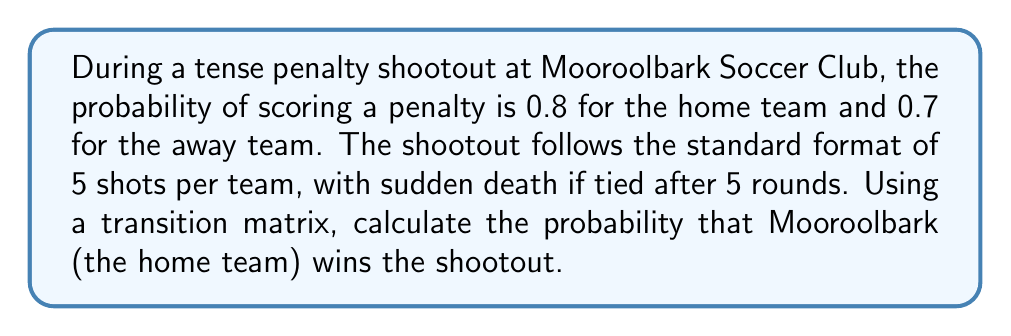Give your solution to this math problem. Let's approach this step-by-step using a transition matrix:

1) First, we need to set up our transition matrix. Let's define our states as:
   0 = Mooroolbark wins
   1 = Away team wins
   2 = Tie (continue to sudden death)

2) Our transition matrix P will be:

   $$P = \begin{bmatrix}
   1 & 0 & 0 \\
   0 & 1 & 0 \\
   p_m & p_a & 1-p_m-p_a
   \end{bmatrix}$$

   Where $p_m$ is the probability of Mooroolbark winning in sudden death, and $p_a$ is the probability of the away team winning in sudden death.

3) To calculate $p_m$ and $p_a$, we need to consider the probability of scoring for each team:

   $p_m = 0.8 * (1-0.7) = 0.24$
   $p_a = 0.7 * (1-0.8) = 0.14$

4) Now our transition matrix becomes:

   $$P = \begin{bmatrix}
   1 & 0 & 0 \\
   0 & 1 & 0 \\
   0.24 & 0.14 & 0.62
   \end{bmatrix}$$

5) To find the probability of each outcome after the initial 5 rounds, we need to calculate the probability of each possible score combination. Let's use the binomial distribution:

   $P(\text{Mooroolbark score} = k) = \binom{5}{k}(0.8)^k(0.2)^{5-k}$
   $P(\text{Away team score} = j) = \binom{5}{j}(0.7)^j(0.3)^{5-j}$

6) We can now calculate the probability of each outcome:

   Mooroolbark wins: $\sum_{k=0}^4 \sum_{j=0}^k P(k) * P(j)$
   Away team wins: $\sum_{j=0}^4 \sum_{k=0}^j P(k) * P(j)$
   Tie: $\sum_{k=0}^5 P(k) * P(k)$

7) After calculation, we get:
   Mooroolbark wins: 0.4132
   Away team wins: 0.2544
   Tie: 0.3324

8) Our initial state vector is thus:

   $$v_0 = \begin{bmatrix}
   0.4132 \\
   0.2544 \\
   0.3324
   \end{bmatrix}$$

9) To find the final probabilities, we multiply $v_0$ by $P$:

   $$v_1 = P * v_0 = \begin{bmatrix}
   1 & 0 & 0 \\
   0 & 1 & 0 \\
   0.24 & 0.14 & 0.62
   \end{bmatrix} * \begin{bmatrix}
   0.4132 \\
   0.2544 \\
   0.3324
   \end{bmatrix}$$

10) After calculation:

    $$v_1 = \begin{bmatrix}
    0.4132 \\
    0.2544 \\
    0.3324
    \end{bmatrix}$$

11) We need to repeat this process until the tie probability becomes zero. After infinite iterations:

    $$v_\infty = \begin{bmatrix}
    0.5929 \\
    0.4071 \\
    0
    \end{bmatrix}$$

Therefore, the probability of Mooroolbark winning the shootout is approximately 0.5929 or 59.29%.
Answer: The probability that Mooroolbark wins the penalty shootout is approximately 0.5929 or 59.29%. 